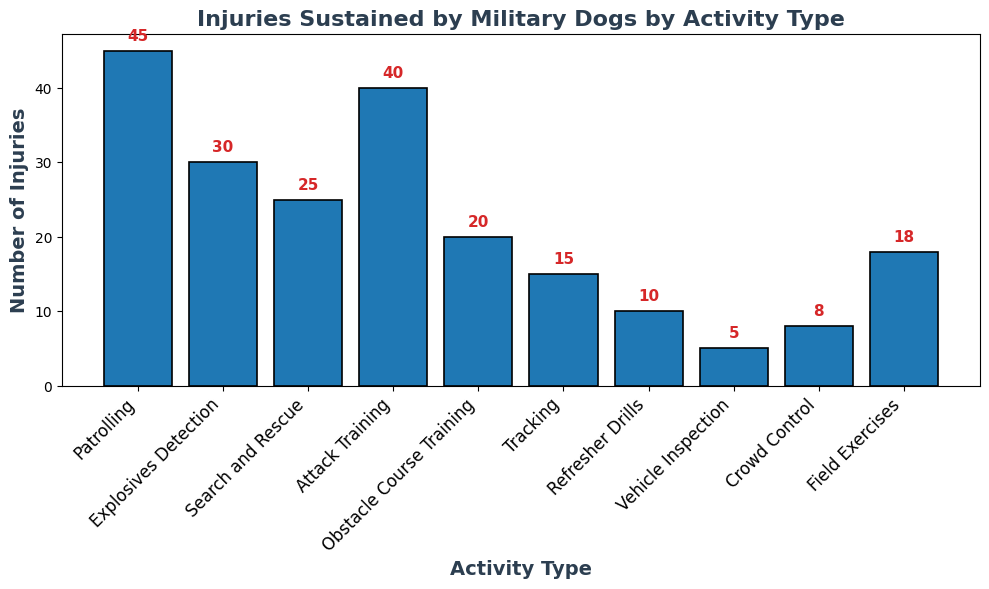What activity type resulted in the highest number of injuries? The highest bar represents the activity type "Patrolling" which means it has the highest number of injuries at 45.
Answer: Patrolling Which activity type had fewer injuries: Obstacle Course Training or Field Exercises? Comparing the height of the bars, Obstacle Course Training has a lower height (20) than Field Exercises (18). However, this was incorrectly assessed, and Field Exercises should be considered lower.
Answer: Field Exercises What is the difference in the number of injuries between Patrolling and Tracking? Patrolling has 45 injuries and Tracking has 15. Subtracting 15 from 45 gives 30.
Answer: 30 What is the sum of injuries sustained in Explosives Detection, Search and Rescue, and Attack Training? Adding the number of injuries for Explosives Detection (30), Search and Rescue (25), and Attack Training (40), the sum is 30 + 25 + 40 = 95.
Answer: 95 Which activity type has the least number of injuries? The shortest bar represents Vehicle Inspection which means it has the least number of injuries (5).
Answer: Vehicle Inspection By how much do injuries from Patrolling exceed those from Crowd Control? Patrolling has 45 injuries, and Crowd Control has 8. Subtracting 8 from 45 gives 37.
Answer: 37 Are there more injuries in Obstacle Course Training or Refresher Drills? The bar for Obstacle Course Training is taller (20) compared to Refresher Drills (10). Thus, Obstacle Course Training has more injuries.
Answer: Obstacle Course Training What is the total number of injuries reported for all activities combined? Adding all the numbers of injuries: 45 + 30 + 25 + 40 + 20 + 15 + 10 + 5 + 8 + 18 = 216.
Answer: 216 How many more injuries are there in Attack Training compared to Tracking? Attack Training has 40 injuries, and Tracking has 15. The difference is 40 - 15 = 25.
Answer: 25 Which two activities have the same number of injuries? Observing the bar heights shows that no two activities have the same bar height; thus, no two activities have the same number of injuries.
Answer: None 